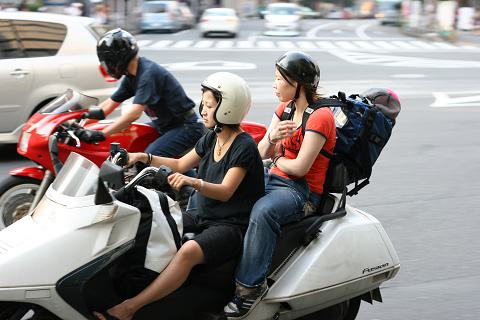Considering the scene, what might be the potential challenges for pedestrians in this area? Pedestrians in this area might face challenges such as navigating through densely populated streets with busy traffic, which includes a mix of cars and motorcycles. The risk of accidents could be higher, and the noise and exhaust fumes from the vehicles could also impact the comfort and safety of pedestrians walking along or crossing these roads. 